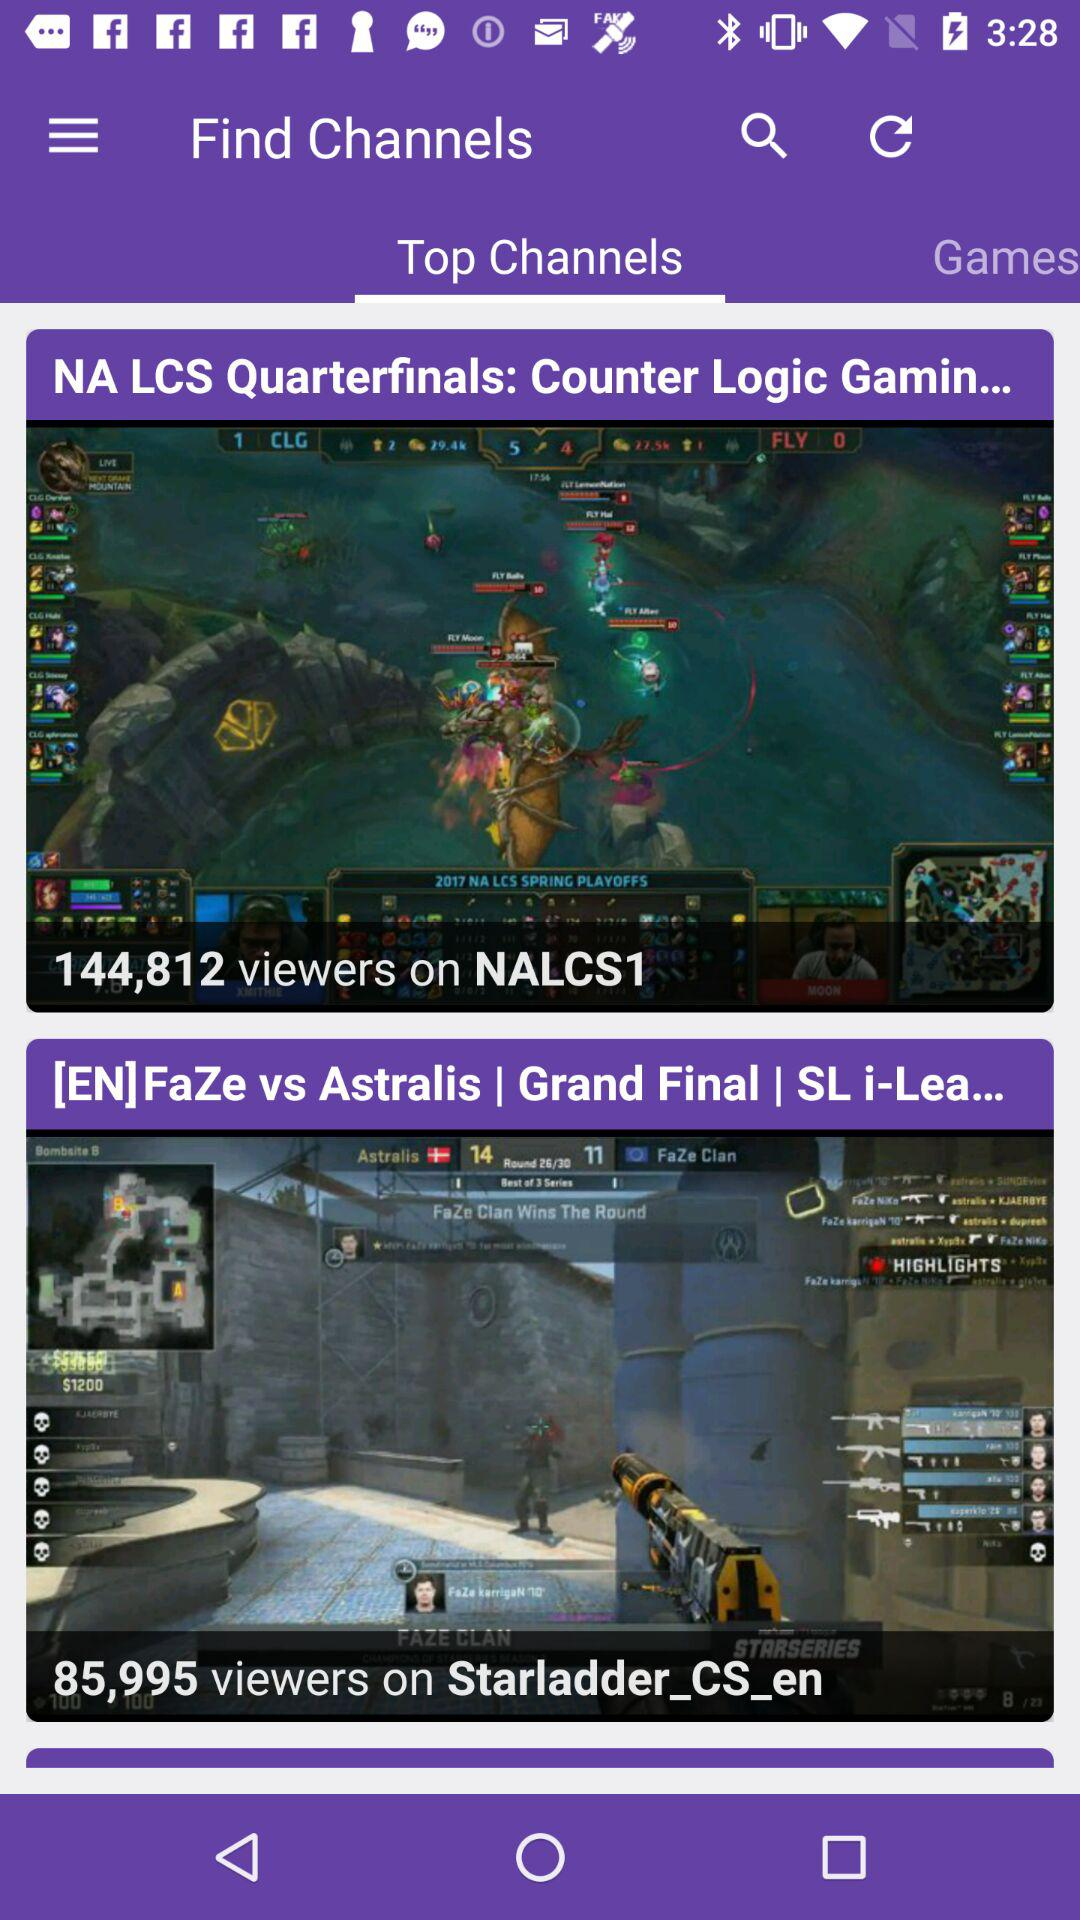How many viewers are there on the "Starladder_CS_en" channels? There are 85,995 viewers. 